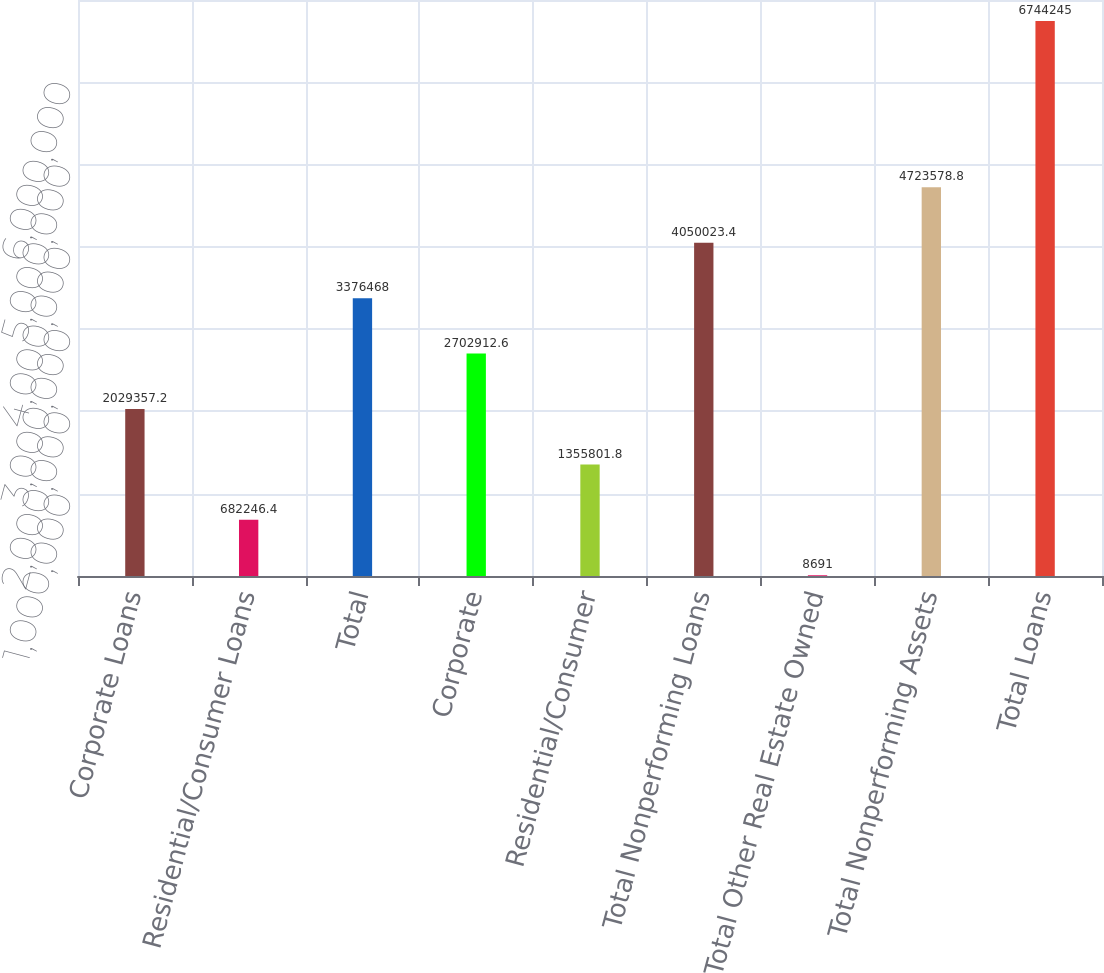Convert chart to OTSL. <chart><loc_0><loc_0><loc_500><loc_500><bar_chart><fcel>Corporate Loans<fcel>Residential/Consumer Loans<fcel>Total<fcel>Corporate<fcel>Residential/Consumer<fcel>Total Nonperforming Loans<fcel>Total Other Real Estate Owned<fcel>Total Nonperforming Assets<fcel>Total Loans<nl><fcel>2.02936e+06<fcel>682246<fcel>3.37647e+06<fcel>2.70291e+06<fcel>1.3558e+06<fcel>4.05002e+06<fcel>8691<fcel>4.72358e+06<fcel>6.74424e+06<nl></chart> 